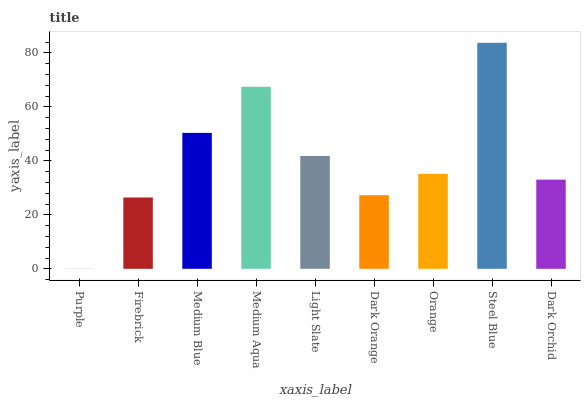Is Purple the minimum?
Answer yes or no. Yes. Is Steel Blue the maximum?
Answer yes or no. Yes. Is Firebrick the minimum?
Answer yes or no. No. Is Firebrick the maximum?
Answer yes or no. No. Is Firebrick greater than Purple?
Answer yes or no. Yes. Is Purple less than Firebrick?
Answer yes or no. Yes. Is Purple greater than Firebrick?
Answer yes or no. No. Is Firebrick less than Purple?
Answer yes or no. No. Is Orange the high median?
Answer yes or no. Yes. Is Orange the low median?
Answer yes or no. Yes. Is Steel Blue the high median?
Answer yes or no. No. Is Dark Orchid the low median?
Answer yes or no. No. 